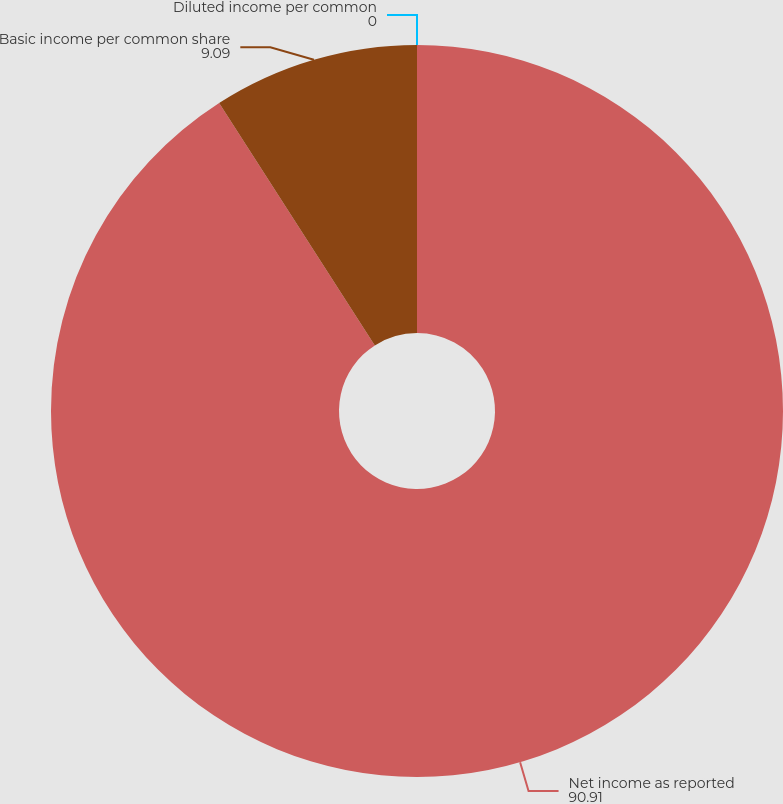<chart> <loc_0><loc_0><loc_500><loc_500><pie_chart><fcel>Net income as reported<fcel>Basic income per common share<fcel>Diluted income per common<nl><fcel>90.91%<fcel>9.09%<fcel>0.0%<nl></chart> 